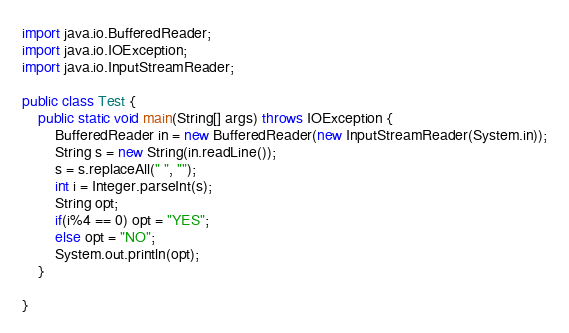<code> <loc_0><loc_0><loc_500><loc_500><_Java_>import java.io.BufferedReader;
import java.io.IOException;
import java.io.InputStreamReader;

public class Test {
	public static void main(String[] args) throws IOException {
		BufferedReader in = new BufferedReader(new InputStreamReader(System.in));
		String s = new String(in.readLine());
		s = s.replaceAll(" ", "");
		int i = Integer.parseInt(s);
		String opt;
		if(i%4 == 0) opt = "YES";
		else opt = "NO";
		System.out.println(opt);
	}

}
</code> 